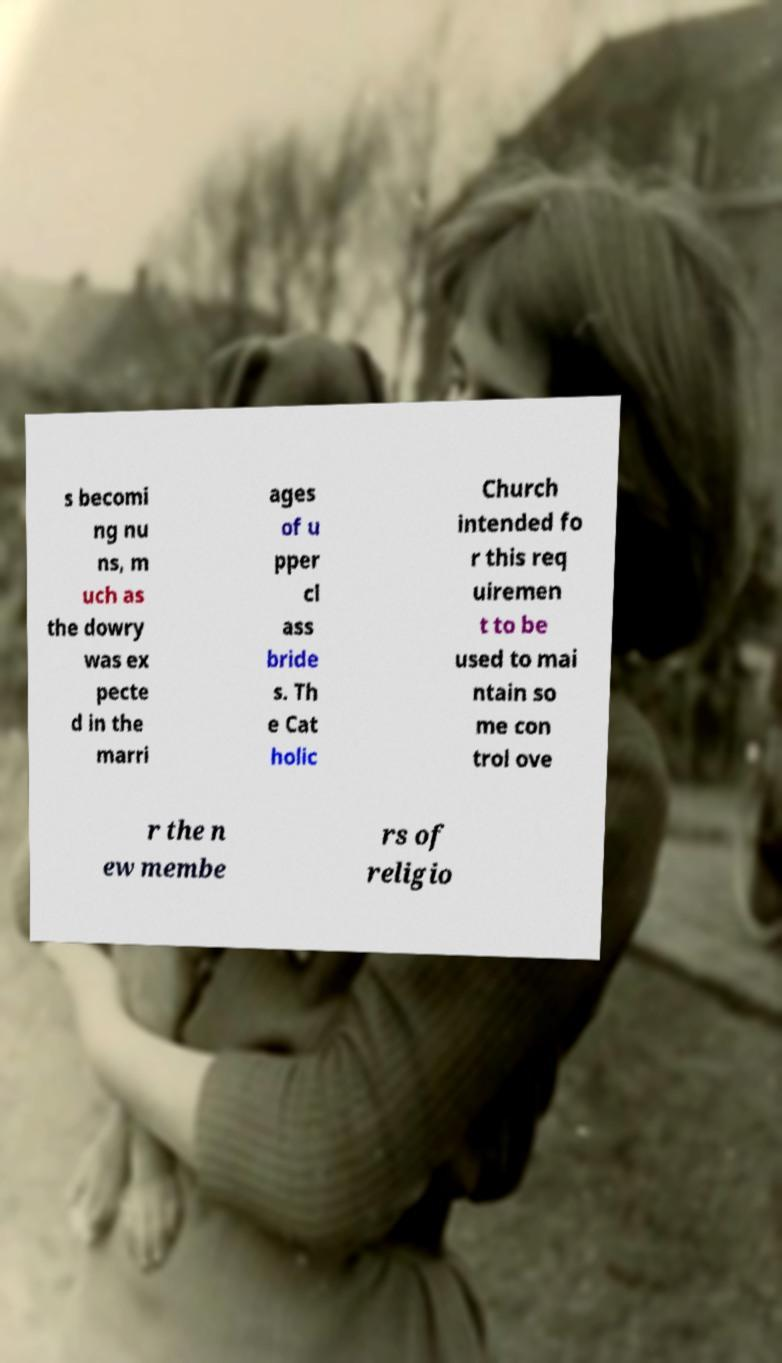For documentation purposes, I need the text within this image transcribed. Could you provide that? s becomi ng nu ns, m uch as the dowry was ex pecte d in the marri ages of u pper cl ass bride s. Th e Cat holic Church intended fo r this req uiremen t to be used to mai ntain so me con trol ove r the n ew membe rs of religio 